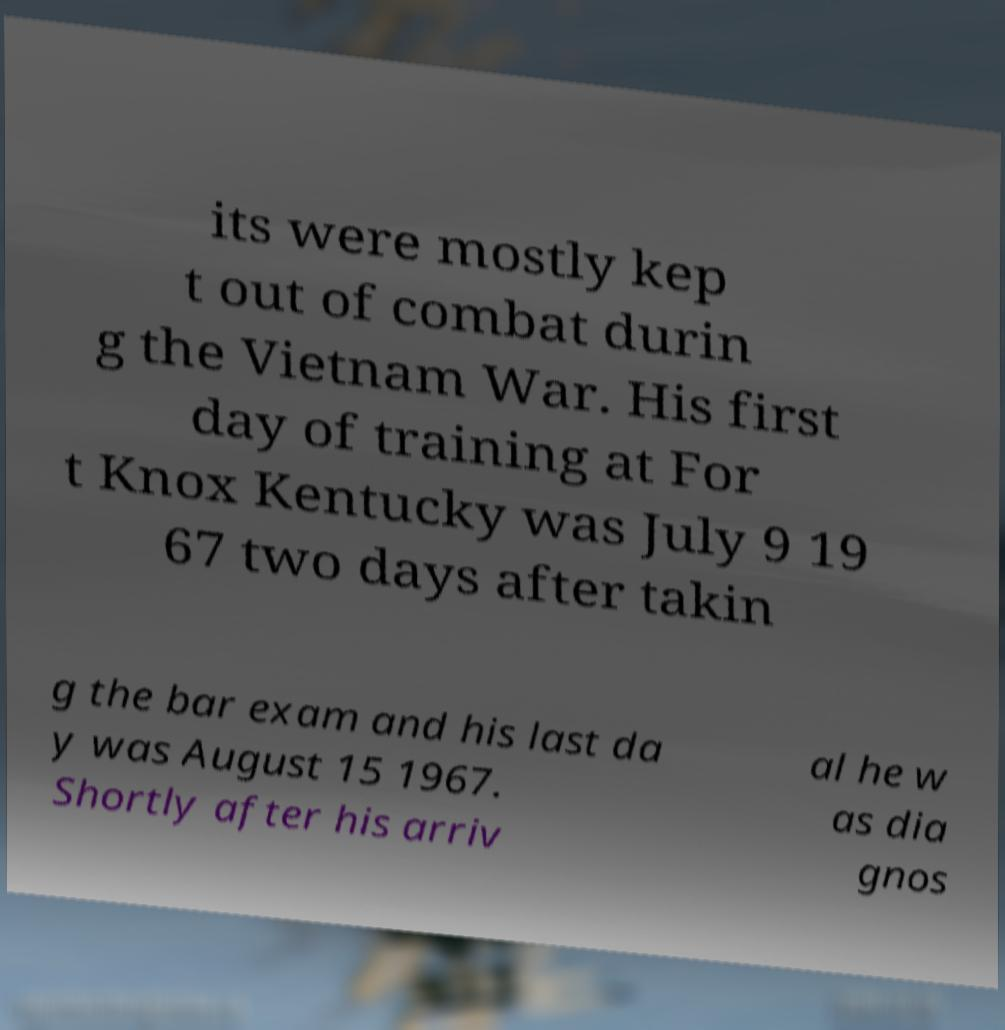What messages or text are displayed in this image? I need them in a readable, typed format. its were mostly kep t out of combat durin g the Vietnam War. His first day of training at For t Knox Kentucky was July 9 19 67 two days after takin g the bar exam and his last da y was August 15 1967. Shortly after his arriv al he w as dia gnos 